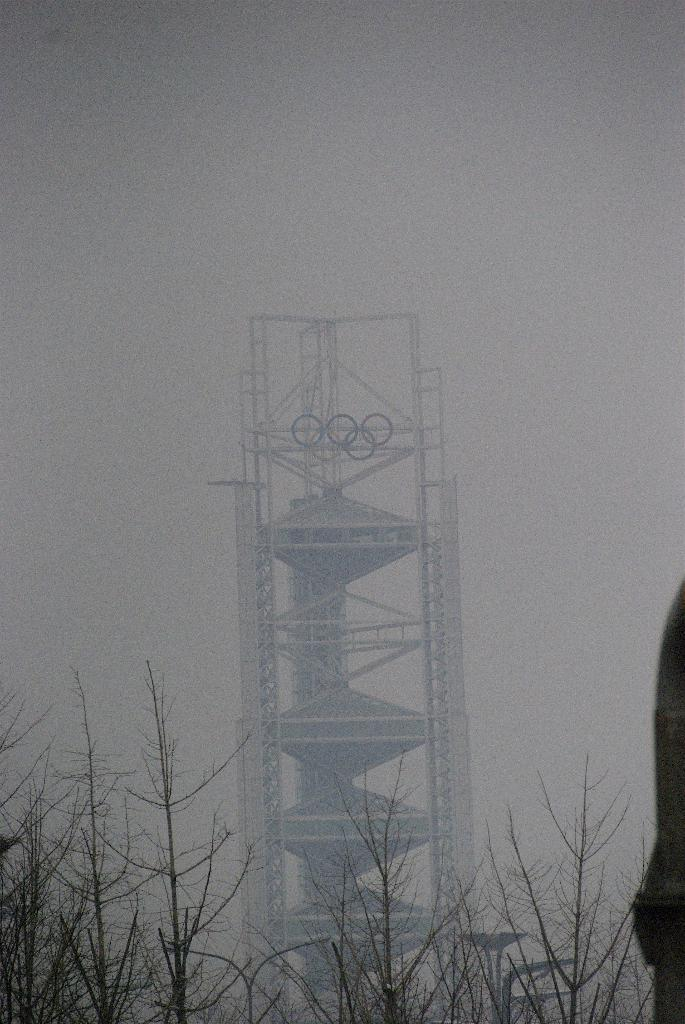What is the main object in the image? There is a machine in the image. How is the machine affected by the environment? The machine is covered with fog. What type of vegetation is present in the image? There are dry plants in the front of the image. Is there a person in the image? Yes, a person is standing beside the dry plants. What books does the person have in their hands in the image? There are no books present in the image. What degree does the person have, as seen in the image? There is no indication of a degree in the image. 